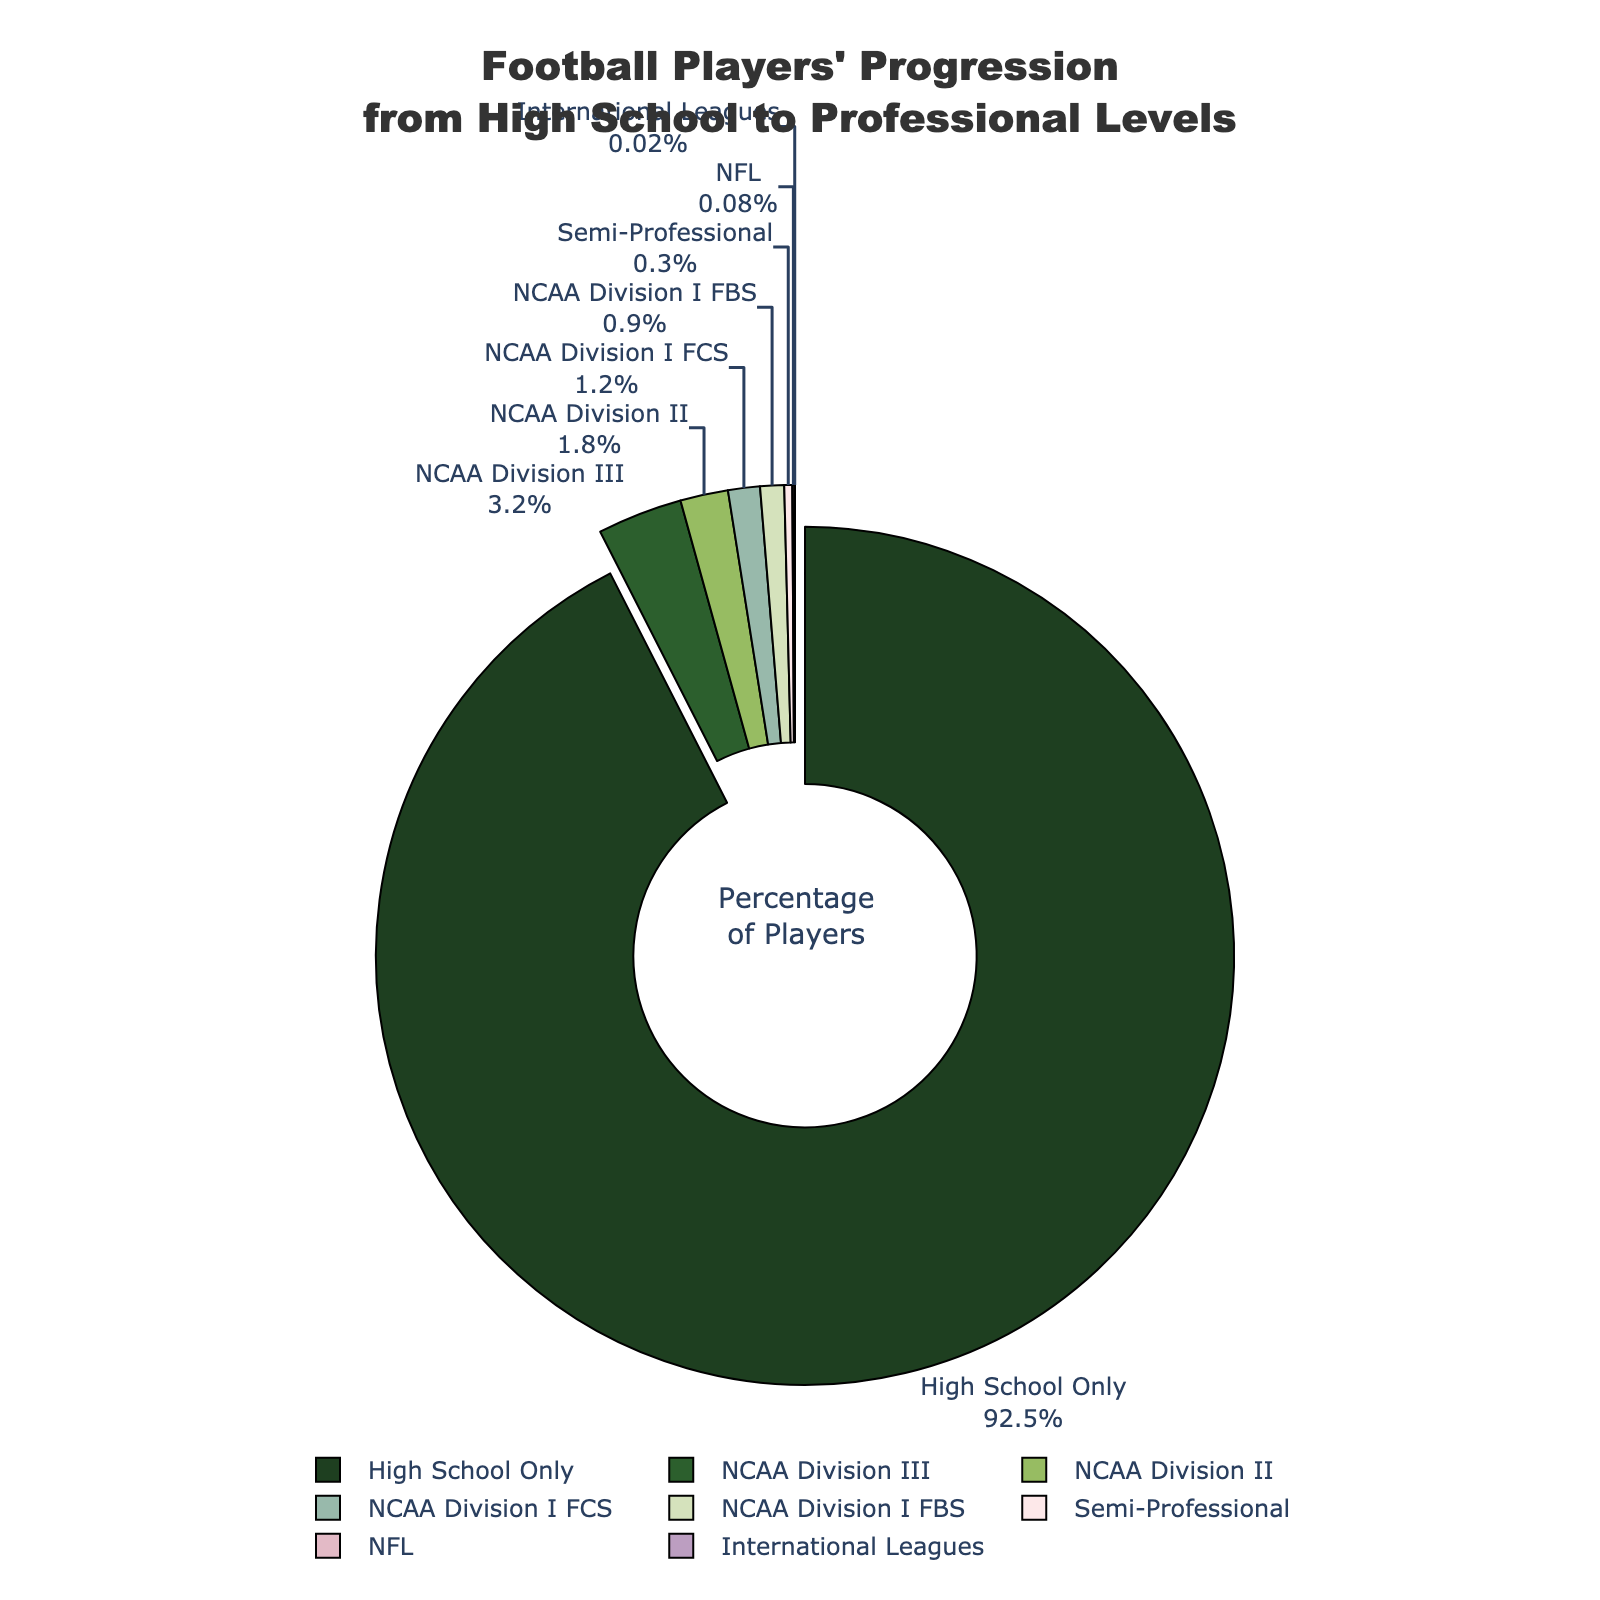What percentage of high school football players advance to NCAA Division I FBS? The figure shows a part labeled "NCAA Division I FBS" with the percentage clearly indicated next to it.
Answer: 0.9 Which level has the highest percentage of high school football players advancing to it? The center of the pie chart highlights the segment with the highest percentage, which is clearly pulled out for emphasis.
Answer: High School Only How does the percentage of players advancing to NCAA Division III compare to those progressing to NCAA Division II? Look at the respective segments for NCAA Division III and NCAA Division II. The percentages are shown; 3.2% (Division III) is greater than 1.8% (Division II).
Answer: NCAA Division III is greater What's the combined percentage of players advancing to semi-professional, NFL, and international leagues? Sum the percentages for Semi-Professional (0.3%), NFL (0.08%), and International Leagues (0.02%). 0.3 + 0.08 + 0.02 = 0.4
Answer: 0.4 What percentage of players advance to any level beyond high school? Subtract the percentage for "High School Only" from 100% to find the percentage for all other levels. 100 - 92.5 = 7.5
Answer: 7.5 Which levels of competition have a visual marker (color) closest to red? Identify and describe the sections of the pie chart that have colors closest to red. Semi-Professional (light pink), NFL (light red), and possibly International Leagues (light purple) seem closest.
Answer: Semi-Professional, NFL, International Leagues What is the difference in the percentage of players advancing to NCAA Division I FCS and NCAA Division III? Compare the percentages for NCAA Division I FCS (1.2%) to NCAA Division III (3.2%) and calculate the difference. 3.2 - 1.2 = 2.0
Answer: 2.0 Which levels of competition have a percentage lower than 1%? Identify the segments with percentages labeled under 1%. This includes NCAA Division I FBS (0.9%), Semi-Professional (0.3%), NFL (0.08%), and International Leagues (0.02%).
Answer: NCAA Division I FBS, Semi-Professional, NFL, International Leagues What portion of the pie chart is taken up by NCAA Division I (both FCS and FBS) levels combined? Sum the percentages for NCAA Division I FCS (1.2%) and NCAA Division I FBS (0.9%) to find the total portion. 1.2 + 0.9 = 2.1
Answer: 2.1 